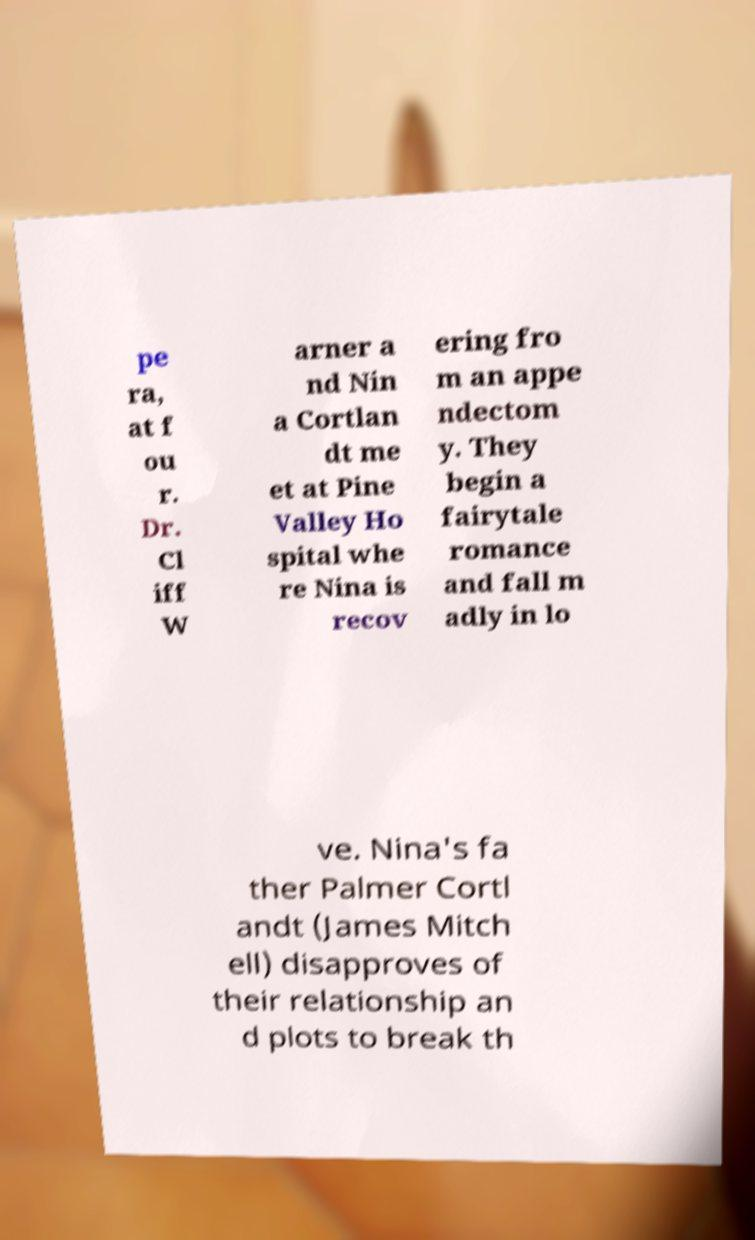Could you assist in decoding the text presented in this image and type it out clearly? pe ra, at f ou r. Dr. Cl iff W arner a nd Nin a Cortlan dt me et at Pine Valley Ho spital whe re Nina is recov ering fro m an appe ndectom y. They begin a fairytale romance and fall m adly in lo ve. Nina's fa ther Palmer Cortl andt (James Mitch ell) disapproves of their relationship an d plots to break th 